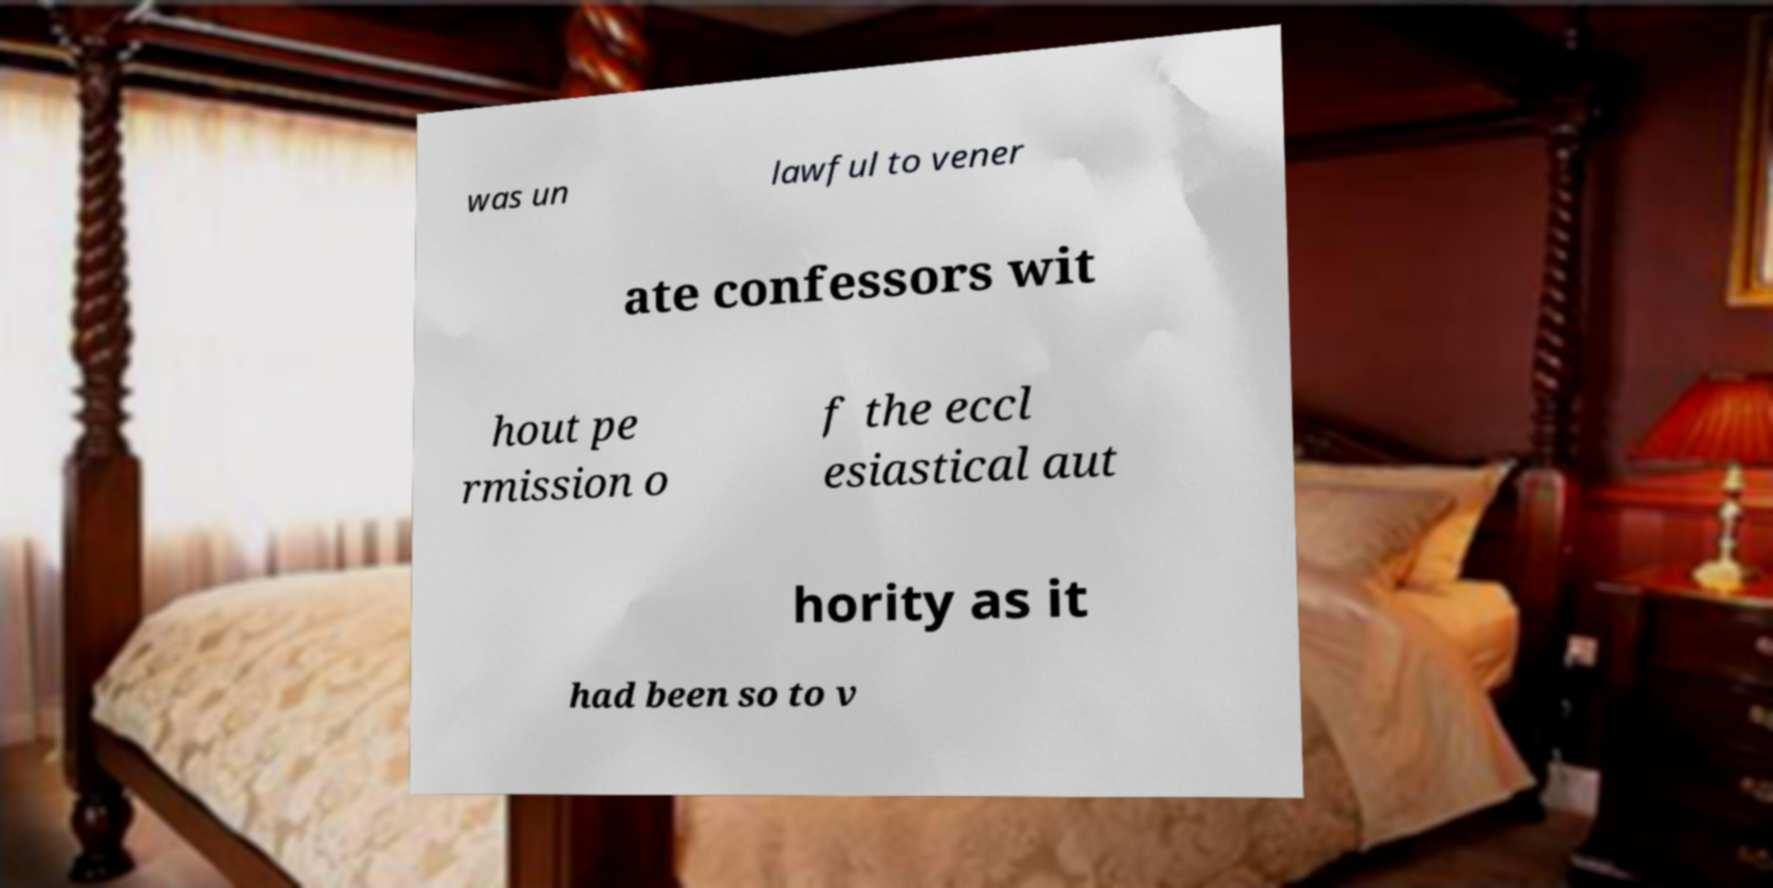What messages or text are displayed in this image? I need them in a readable, typed format. was un lawful to vener ate confessors wit hout pe rmission o f the eccl esiastical aut hority as it had been so to v 